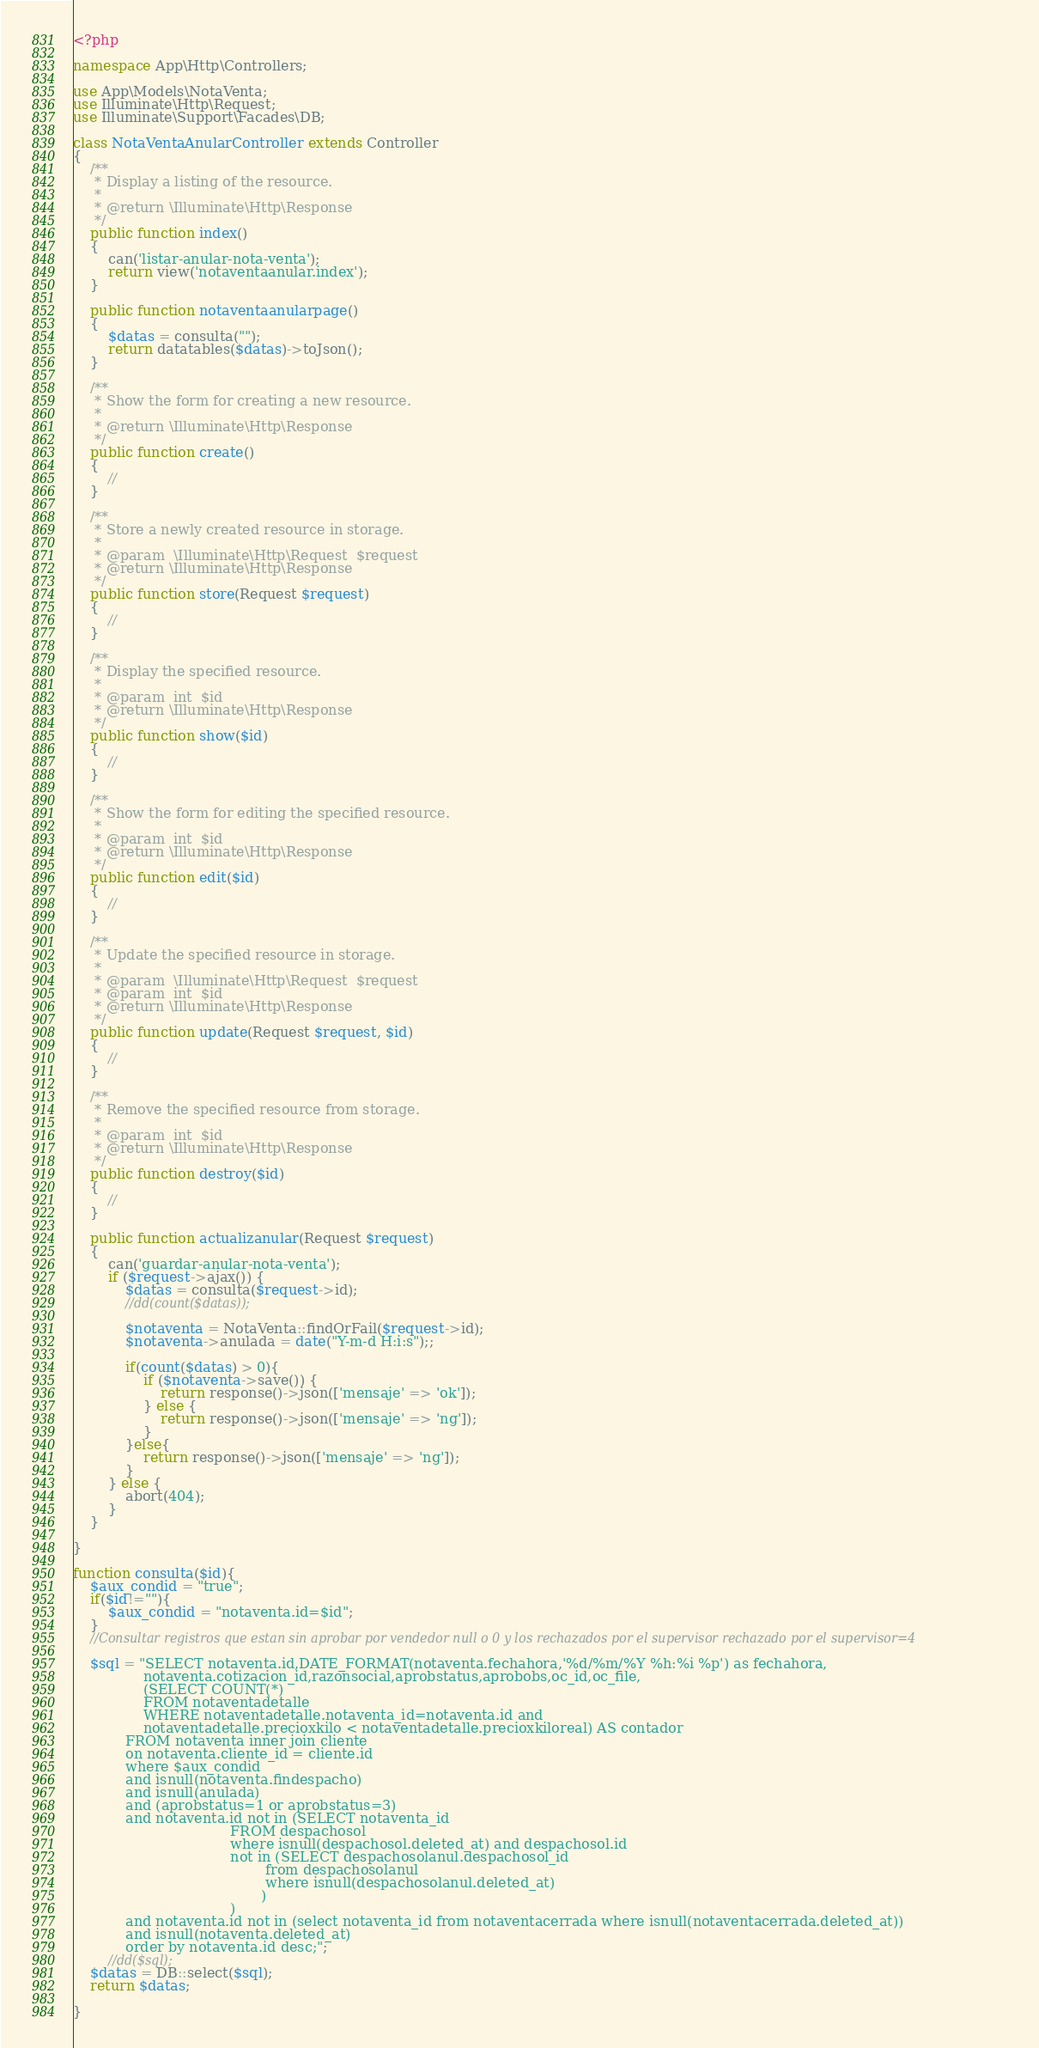Convert code to text. <code><loc_0><loc_0><loc_500><loc_500><_PHP_><?php

namespace App\Http\Controllers;

use App\Models\NotaVenta;
use Illuminate\Http\Request;
use Illuminate\Support\Facades\DB;

class NotaVentaAnularController extends Controller
{
    /**
     * Display a listing of the resource.
     *
     * @return \Illuminate\Http\Response
     */
    public function index()
    {
        can('listar-anular-nota-venta');
        return view('notaventaanular.index');
    }

    public function notaventaanularpage()
    {
        $datas = consulta("");
        return datatables($datas)->toJson(); 
    }

    /**
     * Show the form for creating a new resource.
     *
     * @return \Illuminate\Http\Response
     */
    public function create()
    {
        //
    }

    /**
     * Store a newly created resource in storage.
     *
     * @param  \Illuminate\Http\Request  $request
     * @return \Illuminate\Http\Response
     */
    public function store(Request $request)
    {
        //
    }

    /**
     * Display the specified resource.
     *
     * @param  int  $id
     * @return \Illuminate\Http\Response
     */
    public function show($id)
    {
        //
    }

    /**
     * Show the form for editing the specified resource.
     *
     * @param  int  $id
     * @return \Illuminate\Http\Response
     */
    public function edit($id)
    {
        //
    }

    /**
     * Update the specified resource in storage.
     *
     * @param  \Illuminate\Http\Request  $request
     * @param  int  $id
     * @return \Illuminate\Http\Response
     */
    public function update(Request $request, $id)
    {
        //
    }

    /**
     * Remove the specified resource from storage.
     *
     * @param  int  $id
     * @return \Illuminate\Http\Response
     */
    public function destroy($id)
    {
        //
    }

    public function actualizanular(Request $request)
    {
        can('guardar-anular-nota-venta');
        if ($request->ajax()) {
            $datas = consulta($request->id);
            //dd(count($datas));

            $notaventa = NotaVenta::findOrFail($request->id);
            $notaventa->anulada = date("Y-m-d H:i:s");;
            
            if(count($datas) > 0){
                if ($notaventa->save()) {
                    return response()->json(['mensaje' => 'ok']);
                } else {
                    return response()->json(['mensaje' => 'ng']);
                }    
            }else{
                return response()->json(['mensaje' => 'ng']);
            }
        } else {
            abort(404);
        }
    }

}

function consulta($id){
    $aux_condid = "true";
    if($id!=""){
        $aux_condid = "notaventa.id=$id";
    }
    //Consultar registros que estan sin aprobar por vendedor null o 0 y los rechazados por el supervisor rechazado por el supervisor=4

    $sql = "SELECT notaventa.id,DATE_FORMAT(notaventa.fechahora,'%d/%m/%Y %h:%i %p') as fechahora,
                notaventa.cotizacion_id,razonsocial,aprobstatus,aprobobs,oc_id,oc_file,
                (SELECT COUNT(*) 
                FROM notaventadetalle 
                WHERE notaventadetalle.notaventa_id=notaventa.id and 
                notaventadetalle.precioxkilo < notaventadetalle.precioxkiloreal) AS contador
            FROM notaventa inner join cliente
            on notaventa.cliente_id = cliente.id
            where $aux_condid
            and isnull(notaventa.findespacho)
            and isnull(anulada)
            and (aprobstatus=1 or aprobstatus=3)
            and notaventa.id not in (SELECT notaventa_id 
                                    FROM despachosol 
                                    where isnull(despachosol.deleted_at) and despachosol.id 
                                    not in (SELECT despachosolanul.despachosol_id 
                                            from despachosolanul 
                                            where isnull(despachosolanul.deleted_at)
                                           )
                                    )
            and notaventa.id not in (select notaventa_id from notaventacerrada where isnull(notaventacerrada.deleted_at))
            and isnull(notaventa.deleted_at)
            order by notaventa.id desc;";
        //dd($sql);
    $datas = DB::select($sql);
    return $datas;

}</code> 